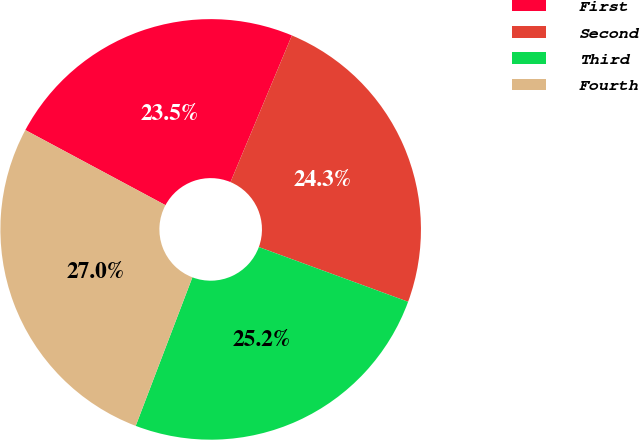Convert chart. <chart><loc_0><loc_0><loc_500><loc_500><pie_chart><fcel>First<fcel>Second<fcel>Third<fcel>Fourth<nl><fcel>23.48%<fcel>24.28%<fcel>25.21%<fcel>27.03%<nl></chart> 